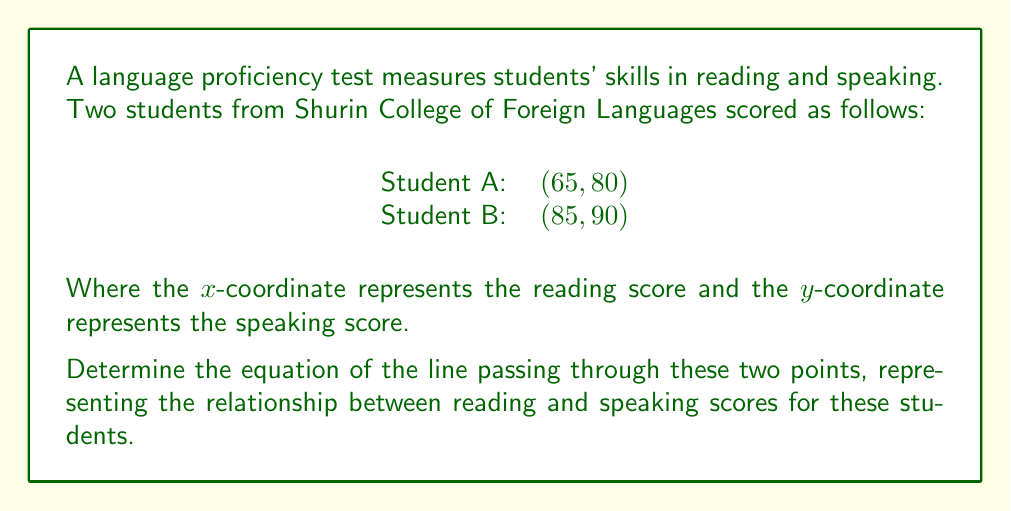Can you answer this question? To find the equation of a line passing through two points, we can use the point-slope form of a line:

$$y - y_1 = m(x - x_1)$$

Where $m$ is the slope of the line, and $(x_1, y_1)$ is a point on the line.

Step 1: Calculate the slope $m$ using the two given points.
$m = \frac{y_2 - y_1}{x_2 - x_1} = \frac{90 - 80}{85 - 65} = \frac{10}{20} = \frac{1}{2}$

Step 2: Choose one of the points to use in the point-slope form. Let's use (65, 80).

Step 3: Substitute the values into the point-slope form:
$$y - 80 = \frac{1}{2}(x - 65)$$

Step 4: Distribute the $\frac{1}{2}$:
$$y - 80 = \frac{1}{2}x - \frac{65}{2}$$

Step 5: Add 80 to both sides to isolate $y$:
$$y = \frac{1}{2}x - \frac{65}{2} + 80$$

Step 6: Simplify:
$$y = \frac{1}{2}x + \frac{95}{2}$$

This is the equation of the line in slope-intercept form $(y = mx + b)$.
Answer: $y = \frac{1}{2}x + \frac{95}{2}$ 